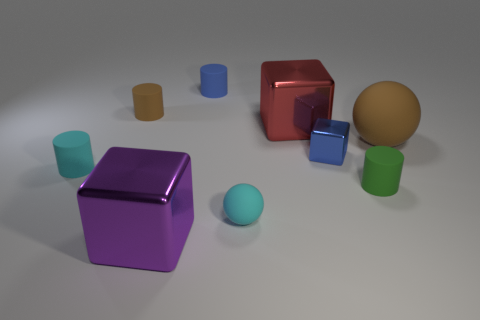There is a cyan thing that is to the left of the purple block; does it have the same shape as the brown matte thing that is to the left of the big brown matte sphere?
Provide a short and direct response. Yes. What number of things are metallic cubes or tiny brown matte objects?
Your answer should be compact. 4. The other purple thing that is the same shape as the tiny metal object is what size?
Your answer should be compact. Large. Is the number of small objects that are left of the large purple metal cube greater than the number of small blue cylinders?
Ensure brevity in your answer.  Yes. Does the large red cube have the same material as the tiny brown cylinder?
Your response must be concise. No. What number of objects are either rubber things right of the small blue rubber cylinder or blocks that are on the right side of the tiny cyan ball?
Offer a very short reply. 5. There is another big object that is the same shape as the red thing; what color is it?
Offer a very short reply. Purple. What number of small cylinders are the same color as the big sphere?
Ensure brevity in your answer.  1. How many objects are small matte objects that are behind the large brown thing or rubber balls?
Your answer should be very brief. 4. There is a large shiny thing that is behind the large metallic thing that is left of the big metallic block behind the small cyan cylinder; what is its color?
Ensure brevity in your answer.  Red. 